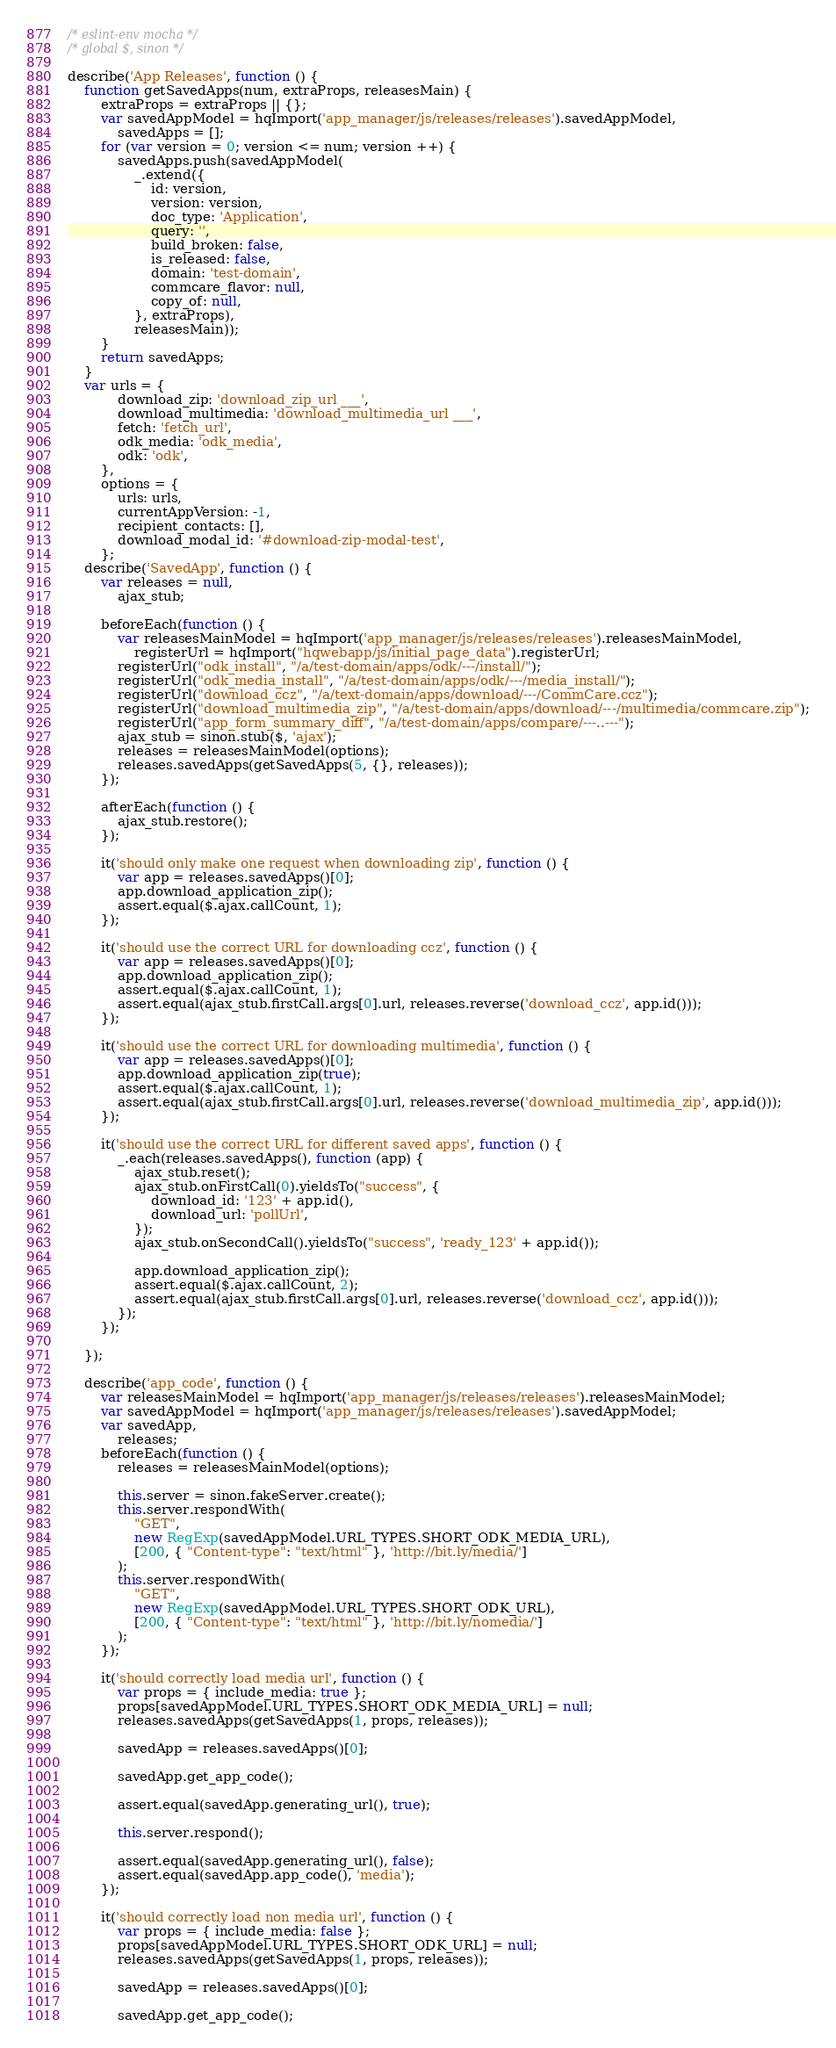Convert code to text. <code><loc_0><loc_0><loc_500><loc_500><_JavaScript_>/* eslint-env mocha */
/* global $, sinon */

describe('App Releases', function () {
    function getSavedApps(num, extraProps, releasesMain) {
        extraProps = extraProps || {};
        var savedAppModel = hqImport('app_manager/js/releases/releases').savedAppModel,
            savedApps = [];
        for (var version = 0; version <= num; version ++) {
            savedApps.push(savedAppModel(
                _.extend({
                    id: version,
                    version: version,
                    doc_type: 'Application',
                    query: '',
                    build_broken: false,
                    is_released: false,
                    domain: 'test-domain',
                    commcare_flavor: null,
                    copy_of: null,
                }, extraProps),
                releasesMain));
        }
        return savedApps;
    }
    var urls = {
            download_zip: 'download_zip_url ___',
            download_multimedia: 'download_multimedia_url ___',
            fetch: 'fetch_url',
            odk_media: 'odk_media',
            odk: 'odk',
        },
        options = {
            urls: urls,
            currentAppVersion: -1,
            recipient_contacts: [],
            download_modal_id: '#download-zip-modal-test',
        };
    describe('SavedApp', function () {
        var releases = null,
            ajax_stub;

        beforeEach(function () {
            var releasesMainModel = hqImport('app_manager/js/releases/releases').releasesMainModel,
                registerUrl = hqImport("hqwebapp/js/initial_page_data").registerUrl;
            registerUrl("odk_install", "/a/test-domain/apps/odk/---/install/");
            registerUrl("odk_media_install", "/a/test-domain/apps/odk/---/media_install/");
            registerUrl("download_ccz", "/a/text-domain/apps/download/---/CommCare.ccz");
            registerUrl("download_multimedia_zip", "/a/test-domain/apps/download/---/multimedia/commcare.zip");
            registerUrl("app_form_summary_diff", "/a/test-domain/apps/compare/---..---");
            ajax_stub = sinon.stub($, 'ajax');
            releases = releasesMainModel(options);
            releases.savedApps(getSavedApps(5, {}, releases));
        });

        afterEach(function () {
            ajax_stub.restore();
        });

        it('should only make one request when downloading zip', function () {
            var app = releases.savedApps()[0];
            app.download_application_zip();
            assert.equal($.ajax.callCount, 1);
        });

        it('should use the correct URL for downloading ccz', function () {
            var app = releases.savedApps()[0];
            app.download_application_zip();
            assert.equal($.ajax.callCount, 1);
            assert.equal(ajax_stub.firstCall.args[0].url, releases.reverse('download_ccz', app.id()));
        });

        it('should use the correct URL for downloading multimedia', function () {
            var app = releases.savedApps()[0];
            app.download_application_zip(true);
            assert.equal($.ajax.callCount, 1);
            assert.equal(ajax_stub.firstCall.args[0].url, releases.reverse('download_multimedia_zip', app.id()));
        });

        it('should use the correct URL for different saved apps', function () {
            _.each(releases.savedApps(), function (app) {
                ajax_stub.reset();
                ajax_stub.onFirstCall(0).yieldsTo("success", {
                    download_id: '123' + app.id(),
                    download_url: 'pollUrl',
                });
                ajax_stub.onSecondCall().yieldsTo("success", 'ready_123' + app.id());

                app.download_application_zip();
                assert.equal($.ajax.callCount, 2);
                assert.equal(ajax_stub.firstCall.args[0].url, releases.reverse('download_ccz', app.id()));
            });
        });

    });

    describe('app_code', function () {
        var releasesMainModel = hqImport('app_manager/js/releases/releases').releasesMainModel;
        var savedAppModel = hqImport('app_manager/js/releases/releases').savedAppModel;
        var savedApp,
            releases;
        beforeEach(function () {
            releases = releasesMainModel(options);

            this.server = sinon.fakeServer.create();
            this.server.respondWith(
                "GET",
                new RegExp(savedAppModel.URL_TYPES.SHORT_ODK_MEDIA_URL),
                [200, { "Content-type": "text/html" }, 'http://bit.ly/media/']
            );
            this.server.respondWith(
                "GET",
                new RegExp(savedAppModel.URL_TYPES.SHORT_ODK_URL),
                [200, { "Content-type": "text/html" }, 'http://bit.ly/nomedia/']
            );
        });

        it('should correctly load media url', function () {
            var props = { include_media: true };
            props[savedAppModel.URL_TYPES.SHORT_ODK_MEDIA_URL] = null;
            releases.savedApps(getSavedApps(1, props, releases));

            savedApp = releases.savedApps()[0];

            savedApp.get_app_code();

            assert.equal(savedApp.generating_url(), true);

            this.server.respond();

            assert.equal(savedApp.generating_url(), false);
            assert.equal(savedApp.app_code(), 'media');
        });

        it('should correctly load non media url', function () {
            var props = { include_media: false };
            props[savedAppModel.URL_TYPES.SHORT_ODK_URL] = null;
            releases.savedApps(getSavedApps(1, props, releases));

            savedApp = releases.savedApps()[0];

            savedApp.get_app_code();
</code> 